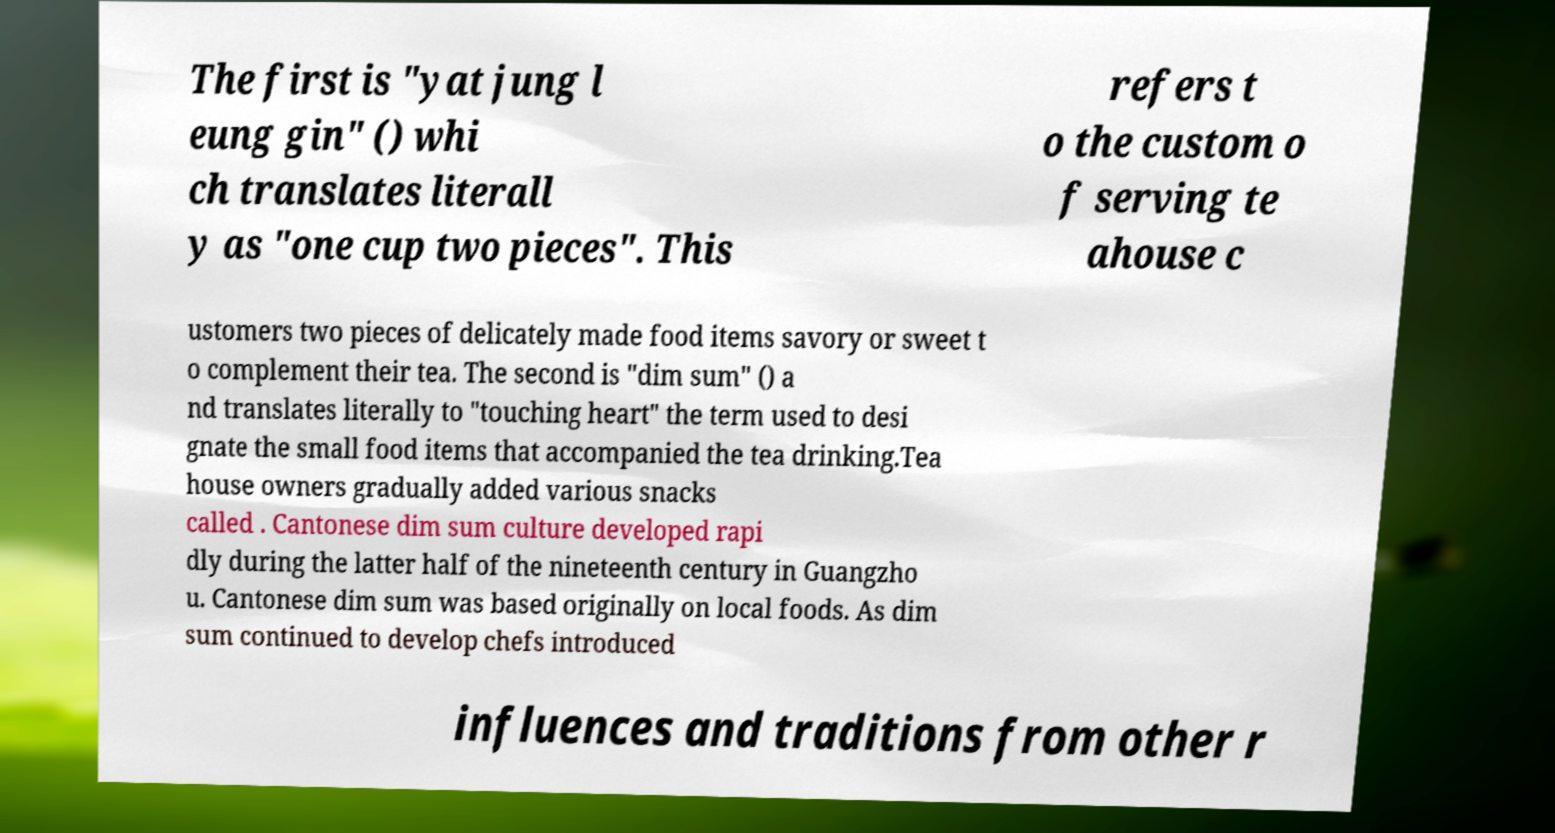Could you assist in decoding the text presented in this image and type it out clearly? The first is "yat jung l eung gin" () whi ch translates literall y as "one cup two pieces". This refers t o the custom o f serving te ahouse c ustomers two pieces of delicately made food items savory or sweet t o complement their tea. The second is "dim sum" () a nd translates literally to "touching heart" the term used to desi gnate the small food items that accompanied the tea drinking.Tea house owners gradually added various snacks called . Cantonese dim sum culture developed rapi dly during the latter half of the nineteenth century in Guangzho u. Cantonese dim sum was based originally on local foods. As dim sum continued to develop chefs introduced influences and traditions from other r 